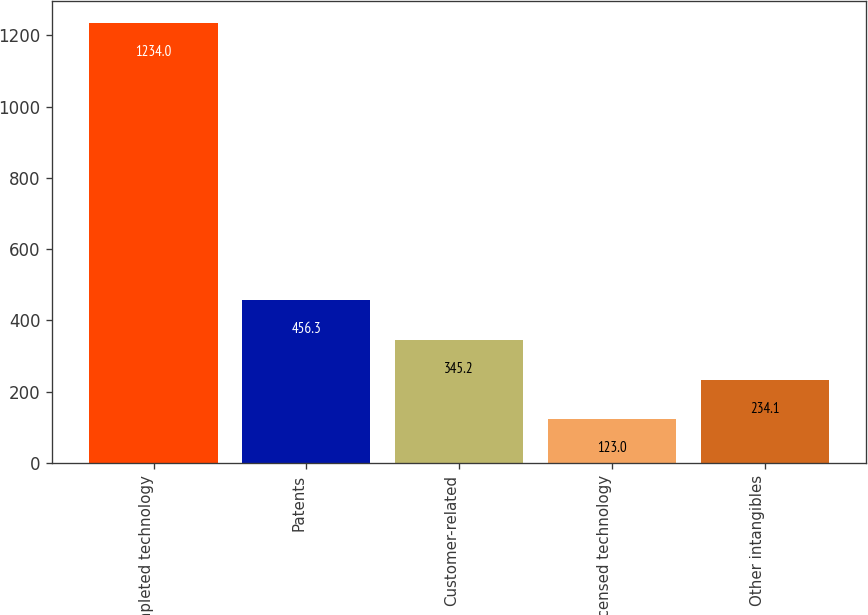Convert chart to OTSL. <chart><loc_0><loc_0><loc_500><loc_500><bar_chart><fcel>Completed technology<fcel>Patents<fcel>Customer-related<fcel>Licensed technology<fcel>Other intangibles<nl><fcel>1234<fcel>456.3<fcel>345.2<fcel>123<fcel>234.1<nl></chart> 